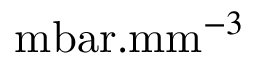<formula> <loc_0><loc_0><loc_500><loc_500>m b a r . m m ^ { - 3 }</formula> 